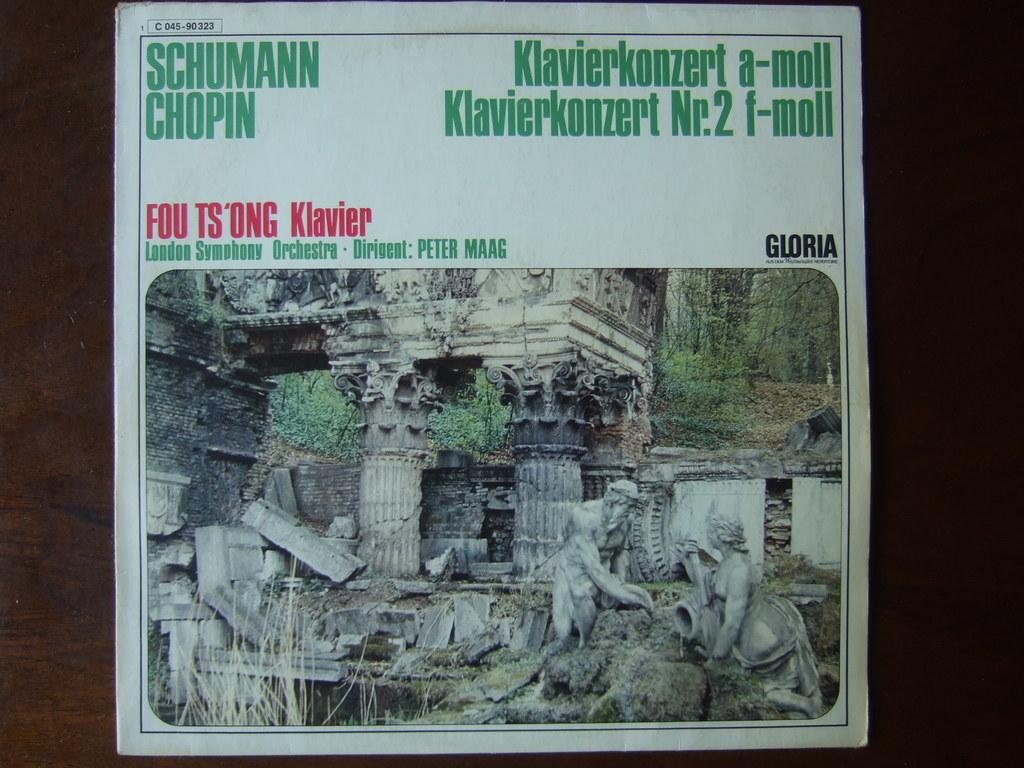What is the main subject of the photo in the image? The photo contains sculptures of people. What other elements can be seen in the photo? The photo contains pillars, trees, and other objects. Is there any text or writing in the image? Yes, there is something written on a paper in the image. How does the visitor in the image react to the cough of the sail? There is no visitor or sail present in the image; it only contains a photo with sculptures, pillars, trees, and other objects. 